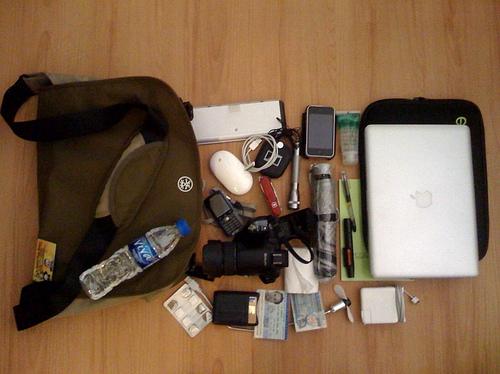Where is the bottled water?
Concise answer only. On bag. What brand is the laptop?
Write a very short answer. Apple. Is there a flashlight among the supplies?
Write a very short answer. Yes. 